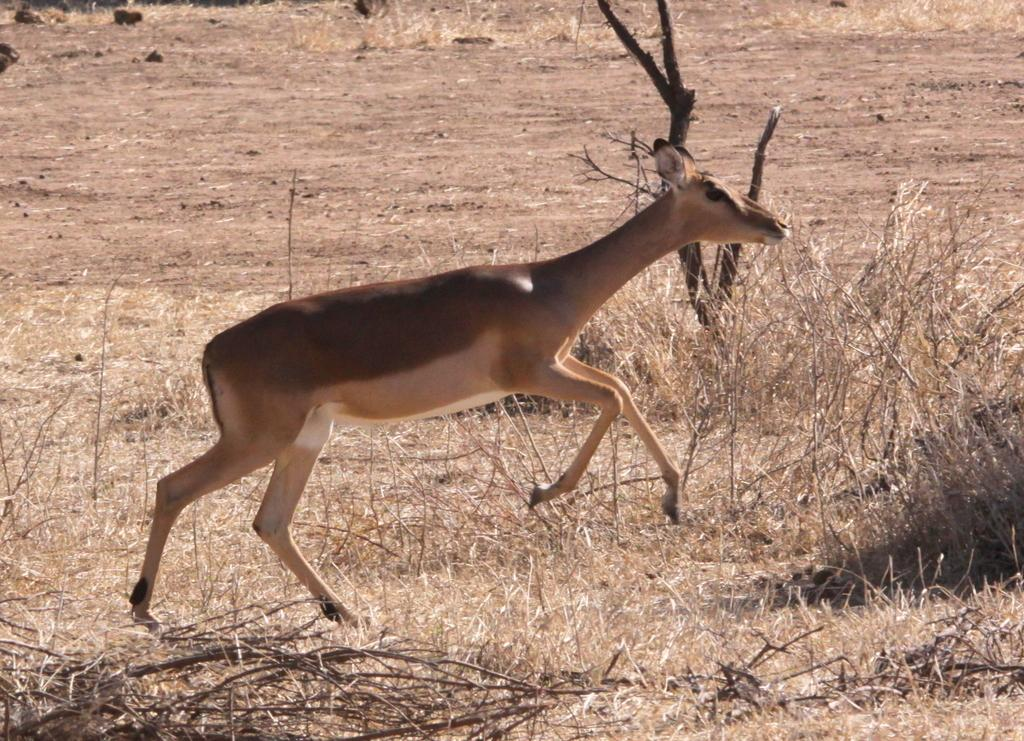What type of vegetation can be seen in the image? There is dry grass in the image. What other natural elements are present in the image? There is mud and small stones in the image. What animal can be seen in the image? There is a deer in the image. What type of quartz can be seen in the image? There is no quartz present in the image. Is the moon visible in the image? The moon is not visible in the image. 